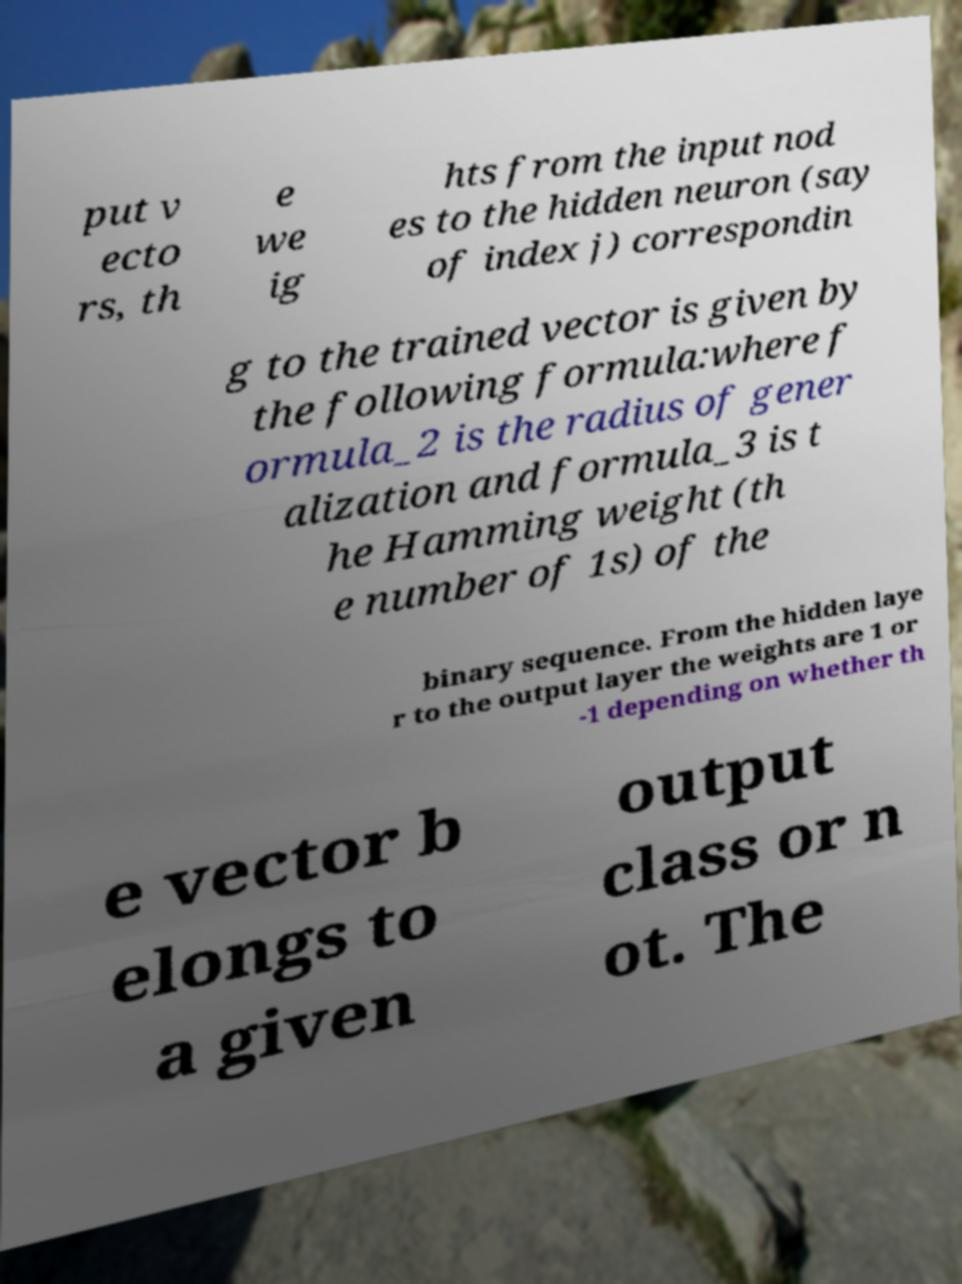Please identify and transcribe the text found in this image. put v ecto rs, th e we ig hts from the input nod es to the hidden neuron (say of index j) correspondin g to the trained vector is given by the following formula:where f ormula_2 is the radius of gener alization and formula_3 is t he Hamming weight (th e number of 1s) of the binary sequence. From the hidden laye r to the output layer the weights are 1 or -1 depending on whether th e vector b elongs to a given output class or n ot. The 